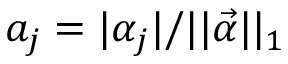Convert formula to latex. <formula><loc_0><loc_0><loc_500><loc_500>a _ { j } = | \alpha _ { j } | / | | \vec { \alpha } | | _ { 1 }</formula> 